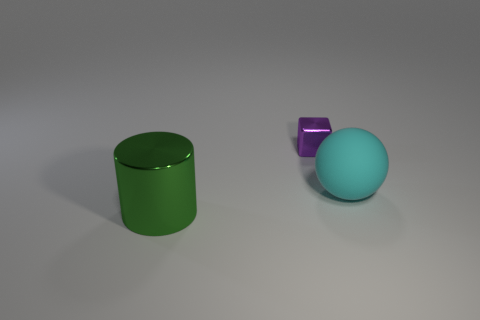Subtract all cylinders. How many objects are left? 2 Add 2 small brown metal blocks. How many objects exist? 5 Subtract all green shiny spheres. Subtract all small purple shiny cubes. How many objects are left? 2 Add 1 big cyan rubber balls. How many big cyan rubber balls are left? 2 Add 3 tiny purple shiny blocks. How many tiny purple shiny blocks exist? 4 Subtract 0 purple cylinders. How many objects are left? 3 Subtract all cyan cubes. Subtract all blue cylinders. How many cubes are left? 1 